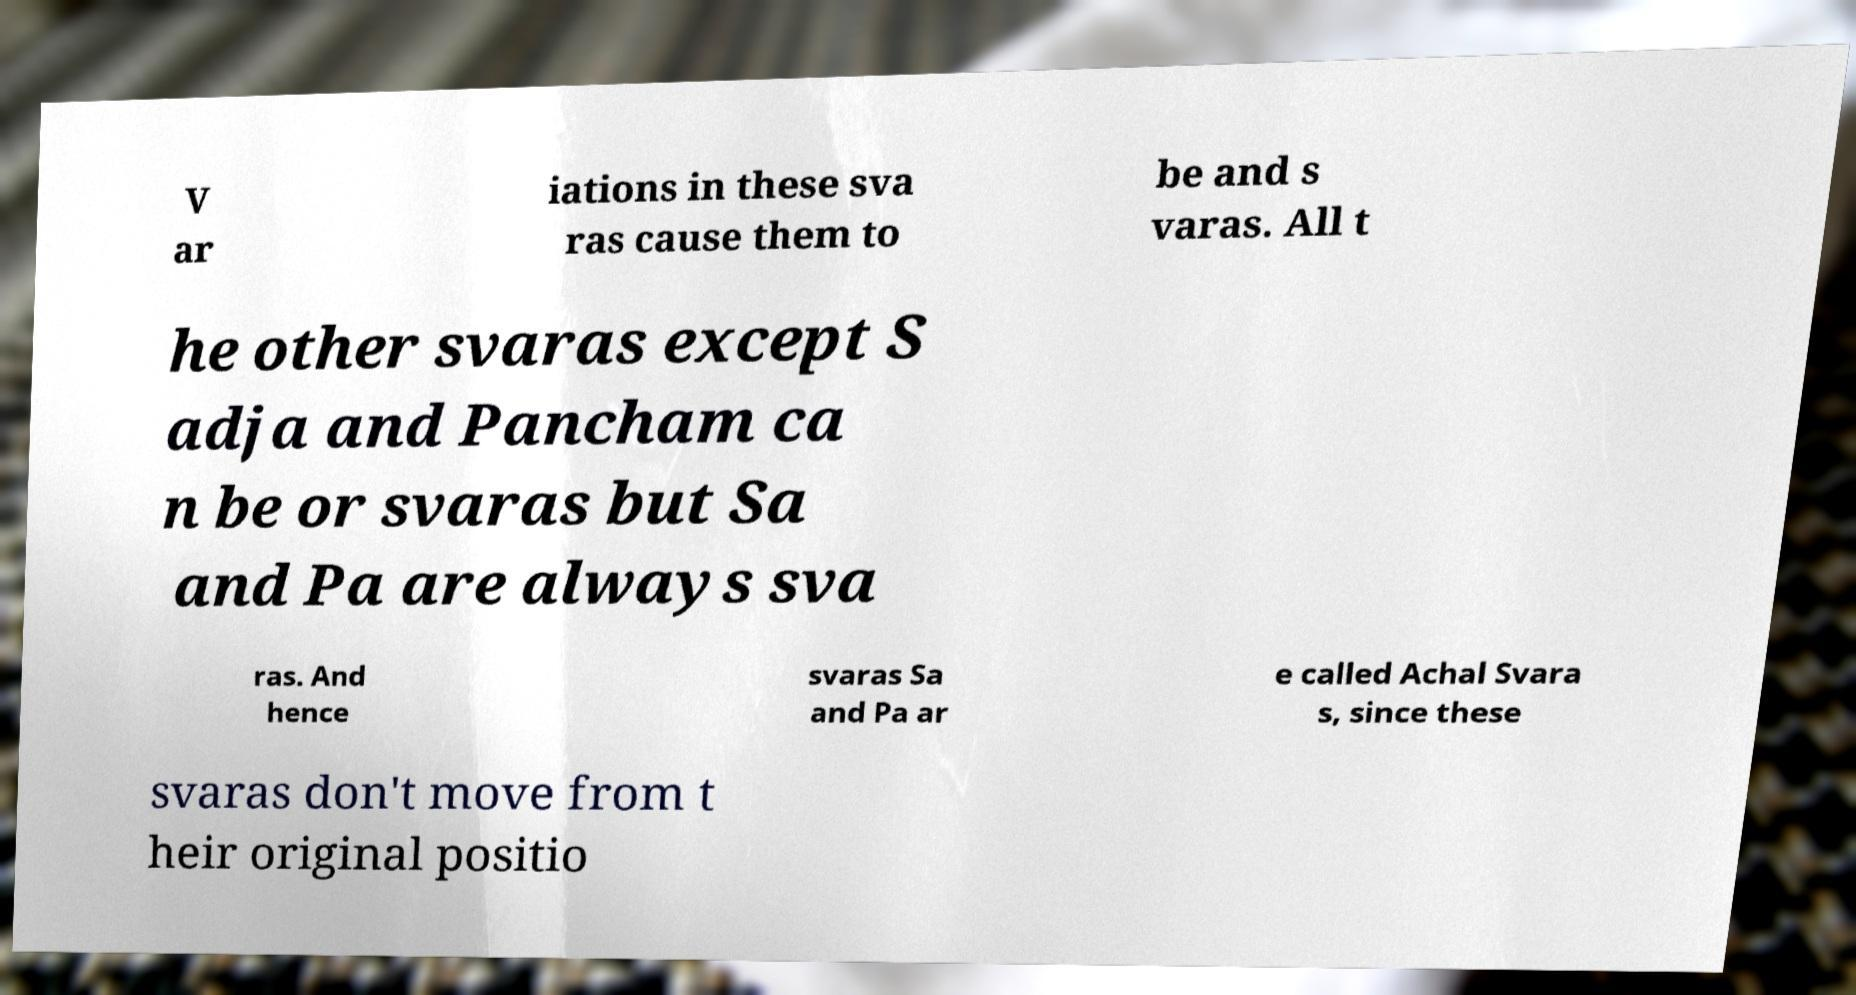Could you extract and type out the text from this image? V ar iations in these sva ras cause them to be and s varas. All t he other svaras except S adja and Pancham ca n be or svaras but Sa and Pa are always sva ras. And hence svaras Sa and Pa ar e called Achal Svara s, since these svaras don't move from t heir original positio 